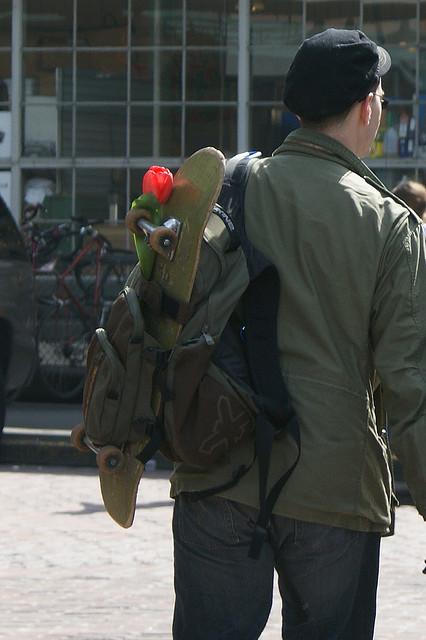Does this person have a skateboard in their backpack?
Short answer required. Yes. What is on his head?
Answer briefly. Hat. What color is his jacket?
Write a very short answer. Green. 